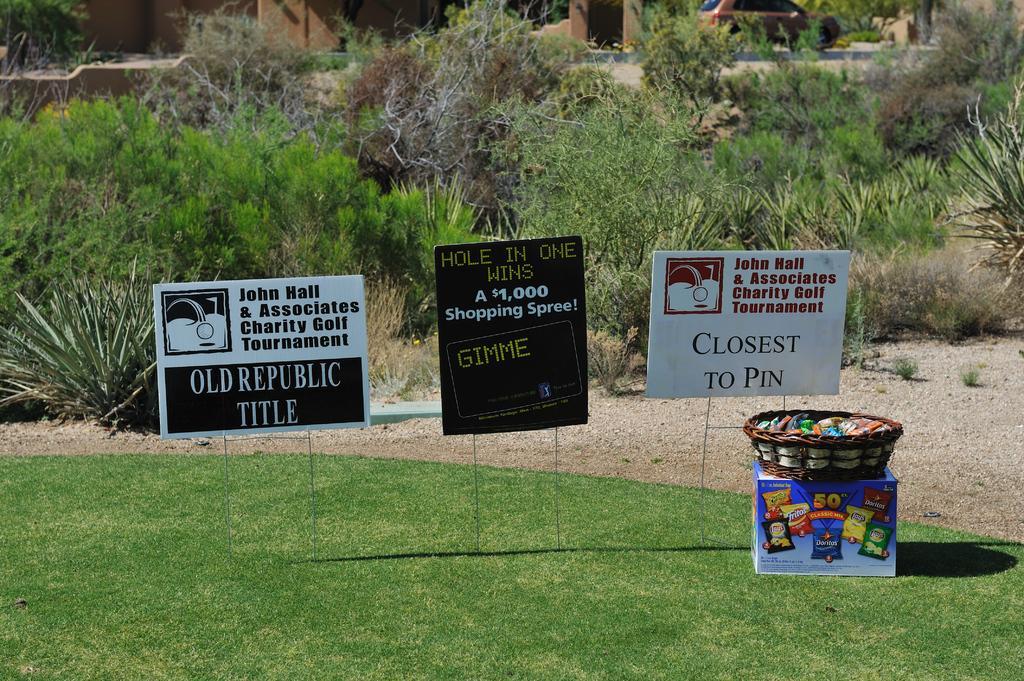Please provide a concise description of this image. In the foreground of this image, there are three boards on the grass and a cardboard box on which there is a basket. In the background, there are plants, a vehicle moving on the road and it seems like buildings on the top. 